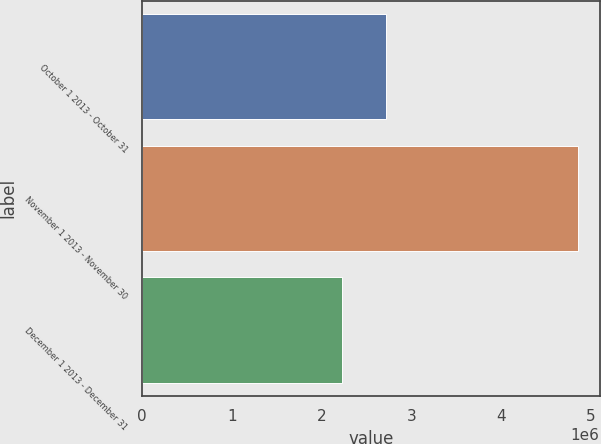Convert chart to OTSL. <chart><loc_0><loc_0><loc_500><loc_500><bar_chart><fcel>October 1 2013 - October 31<fcel>November 1 2013 - November 30<fcel>December 1 2013 - December 31<nl><fcel>2.71847e+06<fcel>4.8559e+06<fcel>2.23021e+06<nl></chart> 